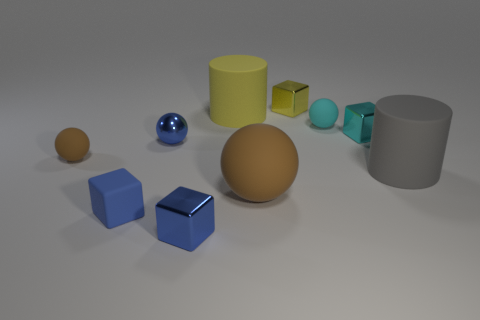There is another big rubber thing that is the same shape as the gray matte object; what is its color?
Your response must be concise. Yellow. What number of green objects are matte cylinders or tiny objects?
Your answer should be compact. 0. What material is the brown ball on the right side of the tiny blue metal thing right of the tiny blue metal sphere made of?
Offer a very short reply. Rubber. Do the small cyan matte object and the cyan metallic thing have the same shape?
Ensure brevity in your answer.  No. The matte cylinder that is the same size as the gray thing is what color?
Your answer should be compact. Yellow. Is there a tiny rubber block that has the same color as the big matte ball?
Provide a short and direct response. No. Is there a sphere?
Offer a very short reply. Yes. Does the blue block that is in front of the small blue matte cube have the same material as the large yellow thing?
Ensure brevity in your answer.  No. The matte object that is the same color as the big matte sphere is what size?
Provide a succinct answer. Small. How many objects are the same size as the gray cylinder?
Your response must be concise. 2. 